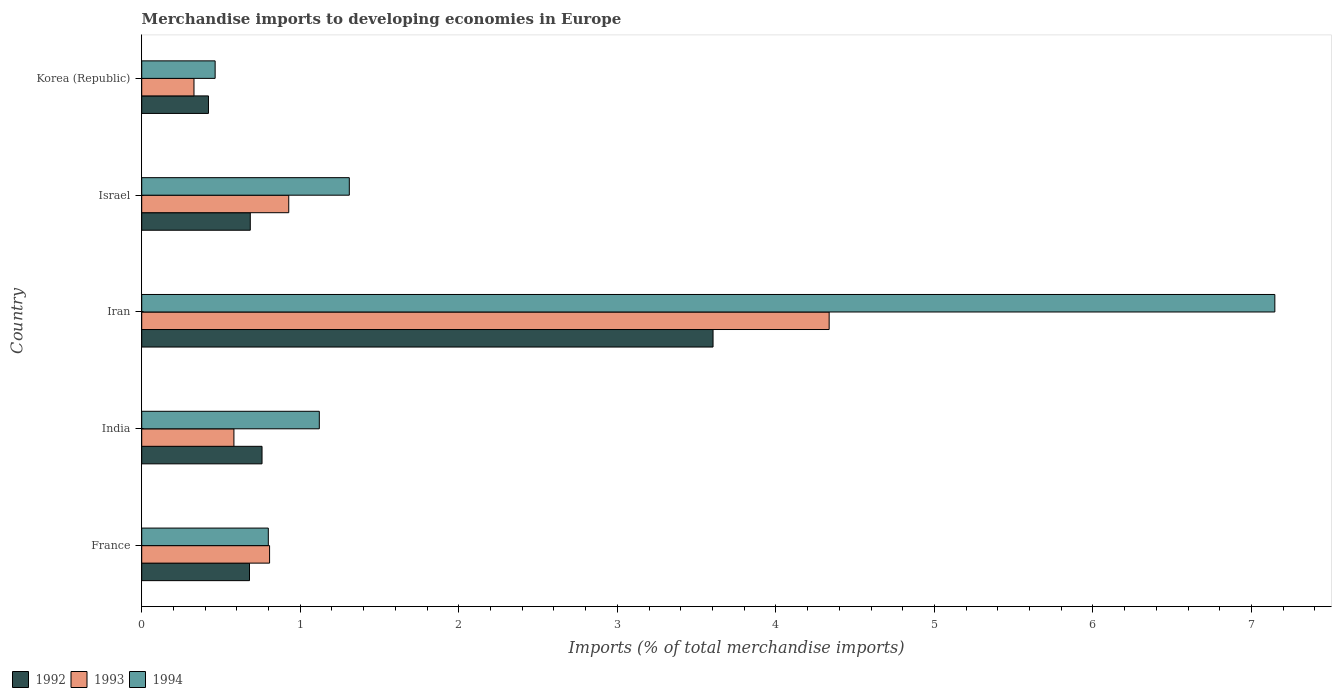How many different coloured bars are there?
Offer a very short reply. 3. Are the number of bars on each tick of the Y-axis equal?
Your answer should be very brief. Yes. How many bars are there on the 4th tick from the top?
Offer a terse response. 3. What is the label of the 4th group of bars from the top?
Give a very brief answer. India. What is the percentage total merchandise imports in 1994 in Iran?
Your answer should be very brief. 7.15. Across all countries, what is the maximum percentage total merchandise imports in 1994?
Give a very brief answer. 7.15. Across all countries, what is the minimum percentage total merchandise imports in 1993?
Provide a succinct answer. 0.33. In which country was the percentage total merchandise imports in 1993 maximum?
Ensure brevity in your answer.  Iran. In which country was the percentage total merchandise imports in 1993 minimum?
Give a very brief answer. Korea (Republic). What is the total percentage total merchandise imports in 1993 in the graph?
Offer a very short reply. 6.98. What is the difference between the percentage total merchandise imports in 1993 in France and that in Iran?
Keep it short and to the point. -3.53. What is the difference between the percentage total merchandise imports in 1993 in France and the percentage total merchandise imports in 1992 in Iran?
Keep it short and to the point. -2.8. What is the average percentage total merchandise imports in 1994 per country?
Provide a succinct answer. 2.17. What is the difference between the percentage total merchandise imports in 1994 and percentage total merchandise imports in 1992 in Iran?
Your answer should be very brief. 3.54. What is the ratio of the percentage total merchandise imports in 1992 in France to that in Israel?
Offer a very short reply. 0.99. Is the percentage total merchandise imports in 1994 in Iran less than that in Israel?
Your response must be concise. No. What is the difference between the highest and the second highest percentage total merchandise imports in 1993?
Offer a terse response. 3.41. What is the difference between the highest and the lowest percentage total merchandise imports in 1992?
Your answer should be compact. 3.18. In how many countries, is the percentage total merchandise imports in 1992 greater than the average percentage total merchandise imports in 1992 taken over all countries?
Your answer should be compact. 1. Is the sum of the percentage total merchandise imports in 1992 in France and Korea (Republic) greater than the maximum percentage total merchandise imports in 1993 across all countries?
Offer a very short reply. No. What does the 3rd bar from the top in France represents?
Give a very brief answer. 1992. How many bars are there?
Your response must be concise. 15. How many countries are there in the graph?
Provide a succinct answer. 5. Are the values on the major ticks of X-axis written in scientific E-notation?
Keep it short and to the point. No. Does the graph contain any zero values?
Ensure brevity in your answer.  No. Where does the legend appear in the graph?
Make the answer very short. Bottom left. How many legend labels are there?
Your response must be concise. 3. What is the title of the graph?
Offer a very short reply. Merchandise imports to developing economies in Europe. What is the label or title of the X-axis?
Ensure brevity in your answer.  Imports (% of total merchandise imports). What is the label or title of the Y-axis?
Your answer should be compact. Country. What is the Imports (% of total merchandise imports) of 1992 in France?
Your response must be concise. 0.68. What is the Imports (% of total merchandise imports) in 1993 in France?
Give a very brief answer. 0.81. What is the Imports (% of total merchandise imports) in 1994 in France?
Ensure brevity in your answer.  0.8. What is the Imports (% of total merchandise imports) of 1992 in India?
Ensure brevity in your answer.  0.76. What is the Imports (% of total merchandise imports) of 1993 in India?
Offer a terse response. 0.58. What is the Imports (% of total merchandise imports) of 1994 in India?
Give a very brief answer. 1.12. What is the Imports (% of total merchandise imports) of 1992 in Iran?
Your answer should be very brief. 3.6. What is the Imports (% of total merchandise imports) of 1993 in Iran?
Ensure brevity in your answer.  4.34. What is the Imports (% of total merchandise imports) of 1994 in Iran?
Offer a terse response. 7.15. What is the Imports (% of total merchandise imports) in 1992 in Israel?
Make the answer very short. 0.68. What is the Imports (% of total merchandise imports) of 1993 in Israel?
Ensure brevity in your answer.  0.93. What is the Imports (% of total merchandise imports) in 1994 in Israel?
Your response must be concise. 1.31. What is the Imports (% of total merchandise imports) in 1992 in Korea (Republic)?
Provide a short and direct response. 0.42. What is the Imports (% of total merchandise imports) in 1993 in Korea (Republic)?
Your response must be concise. 0.33. What is the Imports (% of total merchandise imports) of 1994 in Korea (Republic)?
Make the answer very short. 0.46. Across all countries, what is the maximum Imports (% of total merchandise imports) of 1992?
Offer a terse response. 3.6. Across all countries, what is the maximum Imports (% of total merchandise imports) of 1993?
Provide a succinct answer. 4.34. Across all countries, what is the maximum Imports (% of total merchandise imports) of 1994?
Make the answer very short. 7.15. Across all countries, what is the minimum Imports (% of total merchandise imports) in 1992?
Give a very brief answer. 0.42. Across all countries, what is the minimum Imports (% of total merchandise imports) in 1993?
Ensure brevity in your answer.  0.33. Across all countries, what is the minimum Imports (% of total merchandise imports) of 1994?
Provide a short and direct response. 0.46. What is the total Imports (% of total merchandise imports) in 1992 in the graph?
Your answer should be very brief. 6.15. What is the total Imports (% of total merchandise imports) in 1993 in the graph?
Offer a very short reply. 6.98. What is the total Imports (% of total merchandise imports) of 1994 in the graph?
Keep it short and to the point. 10.84. What is the difference between the Imports (% of total merchandise imports) of 1992 in France and that in India?
Offer a very short reply. -0.08. What is the difference between the Imports (% of total merchandise imports) in 1993 in France and that in India?
Provide a succinct answer. 0.22. What is the difference between the Imports (% of total merchandise imports) of 1994 in France and that in India?
Give a very brief answer. -0.32. What is the difference between the Imports (% of total merchandise imports) of 1992 in France and that in Iran?
Your response must be concise. -2.92. What is the difference between the Imports (% of total merchandise imports) in 1993 in France and that in Iran?
Ensure brevity in your answer.  -3.53. What is the difference between the Imports (% of total merchandise imports) of 1994 in France and that in Iran?
Offer a very short reply. -6.35. What is the difference between the Imports (% of total merchandise imports) in 1992 in France and that in Israel?
Give a very brief answer. -0. What is the difference between the Imports (% of total merchandise imports) in 1993 in France and that in Israel?
Your response must be concise. -0.12. What is the difference between the Imports (% of total merchandise imports) of 1994 in France and that in Israel?
Provide a succinct answer. -0.51. What is the difference between the Imports (% of total merchandise imports) in 1992 in France and that in Korea (Republic)?
Make the answer very short. 0.26. What is the difference between the Imports (% of total merchandise imports) in 1993 in France and that in Korea (Republic)?
Provide a succinct answer. 0.48. What is the difference between the Imports (% of total merchandise imports) in 1994 in France and that in Korea (Republic)?
Keep it short and to the point. 0.34. What is the difference between the Imports (% of total merchandise imports) of 1992 in India and that in Iran?
Offer a terse response. -2.84. What is the difference between the Imports (% of total merchandise imports) of 1993 in India and that in Iran?
Give a very brief answer. -3.75. What is the difference between the Imports (% of total merchandise imports) in 1994 in India and that in Iran?
Ensure brevity in your answer.  -6.03. What is the difference between the Imports (% of total merchandise imports) in 1992 in India and that in Israel?
Your answer should be compact. 0.07. What is the difference between the Imports (% of total merchandise imports) in 1993 in India and that in Israel?
Offer a terse response. -0.35. What is the difference between the Imports (% of total merchandise imports) of 1994 in India and that in Israel?
Give a very brief answer. -0.19. What is the difference between the Imports (% of total merchandise imports) of 1992 in India and that in Korea (Republic)?
Your answer should be very brief. 0.34. What is the difference between the Imports (% of total merchandise imports) in 1993 in India and that in Korea (Republic)?
Give a very brief answer. 0.25. What is the difference between the Imports (% of total merchandise imports) in 1994 in India and that in Korea (Republic)?
Give a very brief answer. 0.66. What is the difference between the Imports (% of total merchandise imports) in 1992 in Iran and that in Israel?
Give a very brief answer. 2.92. What is the difference between the Imports (% of total merchandise imports) of 1993 in Iran and that in Israel?
Offer a terse response. 3.41. What is the difference between the Imports (% of total merchandise imports) in 1994 in Iran and that in Israel?
Provide a short and direct response. 5.84. What is the difference between the Imports (% of total merchandise imports) in 1992 in Iran and that in Korea (Republic)?
Your answer should be very brief. 3.18. What is the difference between the Imports (% of total merchandise imports) of 1993 in Iran and that in Korea (Republic)?
Give a very brief answer. 4.01. What is the difference between the Imports (% of total merchandise imports) of 1994 in Iran and that in Korea (Republic)?
Keep it short and to the point. 6.68. What is the difference between the Imports (% of total merchandise imports) in 1992 in Israel and that in Korea (Republic)?
Make the answer very short. 0.26. What is the difference between the Imports (% of total merchandise imports) in 1993 in Israel and that in Korea (Republic)?
Offer a very short reply. 0.6. What is the difference between the Imports (% of total merchandise imports) in 1994 in Israel and that in Korea (Republic)?
Make the answer very short. 0.85. What is the difference between the Imports (% of total merchandise imports) of 1992 in France and the Imports (% of total merchandise imports) of 1993 in India?
Give a very brief answer. 0.1. What is the difference between the Imports (% of total merchandise imports) of 1992 in France and the Imports (% of total merchandise imports) of 1994 in India?
Your answer should be very brief. -0.44. What is the difference between the Imports (% of total merchandise imports) in 1993 in France and the Imports (% of total merchandise imports) in 1994 in India?
Your answer should be very brief. -0.31. What is the difference between the Imports (% of total merchandise imports) of 1992 in France and the Imports (% of total merchandise imports) of 1993 in Iran?
Provide a short and direct response. -3.66. What is the difference between the Imports (% of total merchandise imports) in 1992 in France and the Imports (% of total merchandise imports) in 1994 in Iran?
Provide a short and direct response. -6.47. What is the difference between the Imports (% of total merchandise imports) in 1993 in France and the Imports (% of total merchandise imports) in 1994 in Iran?
Your response must be concise. -6.34. What is the difference between the Imports (% of total merchandise imports) of 1992 in France and the Imports (% of total merchandise imports) of 1993 in Israel?
Make the answer very short. -0.25. What is the difference between the Imports (% of total merchandise imports) in 1992 in France and the Imports (% of total merchandise imports) in 1994 in Israel?
Ensure brevity in your answer.  -0.63. What is the difference between the Imports (% of total merchandise imports) of 1993 in France and the Imports (% of total merchandise imports) of 1994 in Israel?
Provide a succinct answer. -0.5. What is the difference between the Imports (% of total merchandise imports) of 1992 in France and the Imports (% of total merchandise imports) of 1993 in Korea (Republic)?
Your answer should be compact. 0.35. What is the difference between the Imports (% of total merchandise imports) in 1992 in France and the Imports (% of total merchandise imports) in 1994 in Korea (Republic)?
Your answer should be very brief. 0.22. What is the difference between the Imports (% of total merchandise imports) of 1993 in France and the Imports (% of total merchandise imports) of 1994 in Korea (Republic)?
Your response must be concise. 0.34. What is the difference between the Imports (% of total merchandise imports) of 1992 in India and the Imports (% of total merchandise imports) of 1993 in Iran?
Keep it short and to the point. -3.58. What is the difference between the Imports (% of total merchandise imports) of 1992 in India and the Imports (% of total merchandise imports) of 1994 in Iran?
Provide a short and direct response. -6.39. What is the difference between the Imports (% of total merchandise imports) of 1993 in India and the Imports (% of total merchandise imports) of 1994 in Iran?
Your answer should be compact. -6.57. What is the difference between the Imports (% of total merchandise imports) in 1992 in India and the Imports (% of total merchandise imports) in 1993 in Israel?
Provide a short and direct response. -0.17. What is the difference between the Imports (% of total merchandise imports) of 1992 in India and the Imports (% of total merchandise imports) of 1994 in Israel?
Offer a very short reply. -0.55. What is the difference between the Imports (% of total merchandise imports) of 1993 in India and the Imports (% of total merchandise imports) of 1994 in Israel?
Your answer should be compact. -0.73. What is the difference between the Imports (% of total merchandise imports) of 1992 in India and the Imports (% of total merchandise imports) of 1993 in Korea (Republic)?
Keep it short and to the point. 0.43. What is the difference between the Imports (% of total merchandise imports) in 1992 in India and the Imports (% of total merchandise imports) in 1994 in Korea (Republic)?
Offer a terse response. 0.3. What is the difference between the Imports (% of total merchandise imports) of 1993 in India and the Imports (% of total merchandise imports) of 1994 in Korea (Republic)?
Provide a short and direct response. 0.12. What is the difference between the Imports (% of total merchandise imports) in 1992 in Iran and the Imports (% of total merchandise imports) in 1993 in Israel?
Your response must be concise. 2.68. What is the difference between the Imports (% of total merchandise imports) in 1992 in Iran and the Imports (% of total merchandise imports) in 1994 in Israel?
Offer a very short reply. 2.29. What is the difference between the Imports (% of total merchandise imports) in 1993 in Iran and the Imports (% of total merchandise imports) in 1994 in Israel?
Give a very brief answer. 3.03. What is the difference between the Imports (% of total merchandise imports) of 1992 in Iran and the Imports (% of total merchandise imports) of 1993 in Korea (Republic)?
Offer a terse response. 3.27. What is the difference between the Imports (% of total merchandise imports) in 1992 in Iran and the Imports (% of total merchandise imports) in 1994 in Korea (Republic)?
Offer a very short reply. 3.14. What is the difference between the Imports (% of total merchandise imports) of 1993 in Iran and the Imports (% of total merchandise imports) of 1994 in Korea (Republic)?
Ensure brevity in your answer.  3.87. What is the difference between the Imports (% of total merchandise imports) of 1992 in Israel and the Imports (% of total merchandise imports) of 1993 in Korea (Republic)?
Your response must be concise. 0.35. What is the difference between the Imports (% of total merchandise imports) of 1992 in Israel and the Imports (% of total merchandise imports) of 1994 in Korea (Republic)?
Offer a very short reply. 0.22. What is the difference between the Imports (% of total merchandise imports) in 1993 in Israel and the Imports (% of total merchandise imports) in 1994 in Korea (Republic)?
Give a very brief answer. 0.46. What is the average Imports (% of total merchandise imports) of 1992 per country?
Offer a very short reply. 1.23. What is the average Imports (% of total merchandise imports) of 1993 per country?
Provide a short and direct response. 1.4. What is the average Imports (% of total merchandise imports) in 1994 per country?
Offer a terse response. 2.17. What is the difference between the Imports (% of total merchandise imports) in 1992 and Imports (% of total merchandise imports) in 1993 in France?
Your response must be concise. -0.13. What is the difference between the Imports (% of total merchandise imports) in 1992 and Imports (% of total merchandise imports) in 1994 in France?
Provide a succinct answer. -0.12. What is the difference between the Imports (% of total merchandise imports) of 1993 and Imports (% of total merchandise imports) of 1994 in France?
Provide a succinct answer. 0.01. What is the difference between the Imports (% of total merchandise imports) of 1992 and Imports (% of total merchandise imports) of 1993 in India?
Your response must be concise. 0.18. What is the difference between the Imports (% of total merchandise imports) of 1992 and Imports (% of total merchandise imports) of 1994 in India?
Provide a short and direct response. -0.36. What is the difference between the Imports (% of total merchandise imports) of 1993 and Imports (% of total merchandise imports) of 1994 in India?
Keep it short and to the point. -0.54. What is the difference between the Imports (% of total merchandise imports) of 1992 and Imports (% of total merchandise imports) of 1993 in Iran?
Provide a succinct answer. -0.73. What is the difference between the Imports (% of total merchandise imports) of 1992 and Imports (% of total merchandise imports) of 1994 in Iran?
Your response must be concise. -3.54. What is the difference between the Imports (% of total merchandise imports) in 1993 and Imports (% of total merchandise imports) in 1994 in Iran?
Keep it short and to the point. -2.81. What is the difference between the Imports (% of total merchandise imports) in 1992 and Imports (% of total merchandise imports) in 1993 in Israel?
Offer a terse response. -0.24. What is the difference between the Imports (% of total merchandise imports) in 1992 and Imports (% of total merchandise imports) in 1994 in Israel?
Ensure brevity in your answer.  -0.62. What is the difference between the Imports (% of total merchandise imports) of 1993 and Imports (% of total merchandise imports) of 1994 in Israel?
Provide a succinct answer. -0.38. What is the difference between the Imports (% of total merchandise imports) of 1992 and Imports (% of total merchandise imports) of 1993 in Korea (Republic)?
Your response must be concise. 0.09. What is the difference between the Imports (% of total merchandise imports) in 1992 and Imports (% of total merchandise imports) in 1994 in Korea (Republic)?
Offer a very short reply. -0.04. What is the difference between the Imports (% of total merchandise imports) of 1993 and Imports (% of total merchandise imports) of 1994 in Korea (Republic)?
Your answer should be compact. -0.13. What is the ratio of the Imports (% of total merchandise imports) in 1992 in France to that in India?
Provide a short and direct response. 0.9. What is the ratio of the Imports (% of total merchandise imports) in 1993 in France to that in India?
Provide a short and direct response. 1.39. What is the ratio of the Imports (% of total merchandise imports) in 1994 in France to that in India?
Provide a short and direct response. 0.71. What is the ratio of the Imports (% of total merchandise imports) of 1992 in France to that in Iran?
Ensure brevity in your answer.  0.19. What is the ratio of the Imports (% of total merchandise imports) in 1993 in France to that in Iran?
Your answer should be very brief. 0.19. What is the ratio of the Imports (% of total merchandise imports) of 1994 in France to that in Iran?
Offer a very short reply. 0.11. What is the ratio of the Imports (% of total merchandise imports) in 1992 in France to that in Israel?
Ensure brevity in your answer.  0.99. What is the ratio of the Imports (% of total merchandise imports) of 1993 in France to that in Israel?
Ensure brevity in your answer.  0.87. What is the ratio of the Imports (% of total merchandise imports) of 1994 in France to that in Israel?
Provide a succinct answer. 0.61. What is the ratio of the Imports (% of total merchandise imports) of 1992 in France to that in Korea (Republic)?
Offer a very short reply. 1.61. What is the ratio of the Imports (% of total merchandise imports) of 1993 in France to that in Korea (Republic)?
Offer a terse response. 2.45. What is the ratio of the Imports (% of total merchandise imports) in 1994 in France to that in Korea (Republic)?
Provide a short and direct response. 1.72. What is the ratio of the Imports (% of total merchandise imports) of 1992 in India to that in Iran?
Your answer should be very brief. 0.21. What is the ratio of the Imports (% of total merchandise imports) of 1993 in India to that in Iran?
Make the answer very short. 0.13. What is the ratio of the Imports (% of total merchandise imports) in 1994 in India to that in Iran?
Ensure brevity in your answer.  0.16. What is the ratio of the Imports (% of total merchandise imports) in 1992 in India to that in Israel?
Offer a terse response. 1.11. What is the ratio of the Imports (% of total merchandise imports) of 1993 in India to that in Israel?
Provide a succinct answer. 0.63. What is the ratio of the Imports (% of total merchandise imports) of 1994 in India to that in Israel?
Make the answer very short. 0.86. What is the ratio of the Imports (% of total merchandise imports) in 1992 in India to that in Korea (Republic)?
Your answer should be compact. 1.8. What is the ratio of the Imports (% of total merchandise imports) of 1993 in India to that in Korea (Republic)?
Keep it short and to the point. 1.76. What is the ratio of the Imports (% of total merchandise imports) of 1994 in India to that in Korea (Republic)?
Your response must be concise. 2.42. What is the ratio of the Imports (% of total merchandise imports) of 1992 in Iran to that in Israel?
Your answer should be very brief. 5.26. What is the ratio of the Imports (% of total merchandise imports) in 1993 in Iran to that in Israel?
Your response must be concise. 4.68. What is the ratio of the Imports (% of total merchandise imports) of 1994 in Iran to that in Israel?
Keep it short and to the point. 5.46. What is the ratio of the Imports (% of total merchandise imports) in 1992 in Iran to that in Korea (Republic)?
Keep it short and to the point. 8.56. What is the ratio of the Imports (% of total merchandise imports) in 1993 in Iran to that in Korea (Republic)?
Offer a terse response. 13.15. What is the ratio of the Imports (% of total merchandise imports) in 1994 in Iran to that in Korea (Republic)?
Your response must be concise. 15.43. What is the ratio of the Imports (% of total merchandise imports) of 1992 in Israel to that in Korea (Republic)?
Provide a succinct answer. 1.63. What is the ratio of the Imports (% of total merchandise imports) in 1993 in Israel to that in Korea (Republic)?
Your answer should be very brief. 2.81. What is the ratio of the Imports (% of total merchandise imports) in 1994 in Israel to that in Korea (Republic)?
Your answer should be very brief. 2.83. What is the difference between the highest and the second highest Imports (% of total merchandise imports) in 1992?
Your answer should be very brief. 2.84. What is the difference between the highest and the second highest Imports (% of total merchandise imports) of 1993?
Provide a short and direct response. 3.41. What is the difference between the highest and the second highest Imports (% of total merchandise imports) in 1994?
Offer a terse response. 5.84. What is the difference between the highest and the lowest Imports (% of total merchandise imports) of 1992?
Your answer should be very brief. 3.18. What is the difference between the highest and the lowest Imports (% of total merchandise imports) in 1993?
Ensure brevity in your answer.  4.01. What is the difference between the highest and the lowest Imports (% of total merchandise imports) in 1994?
Offer a very short reply. 6.68. 